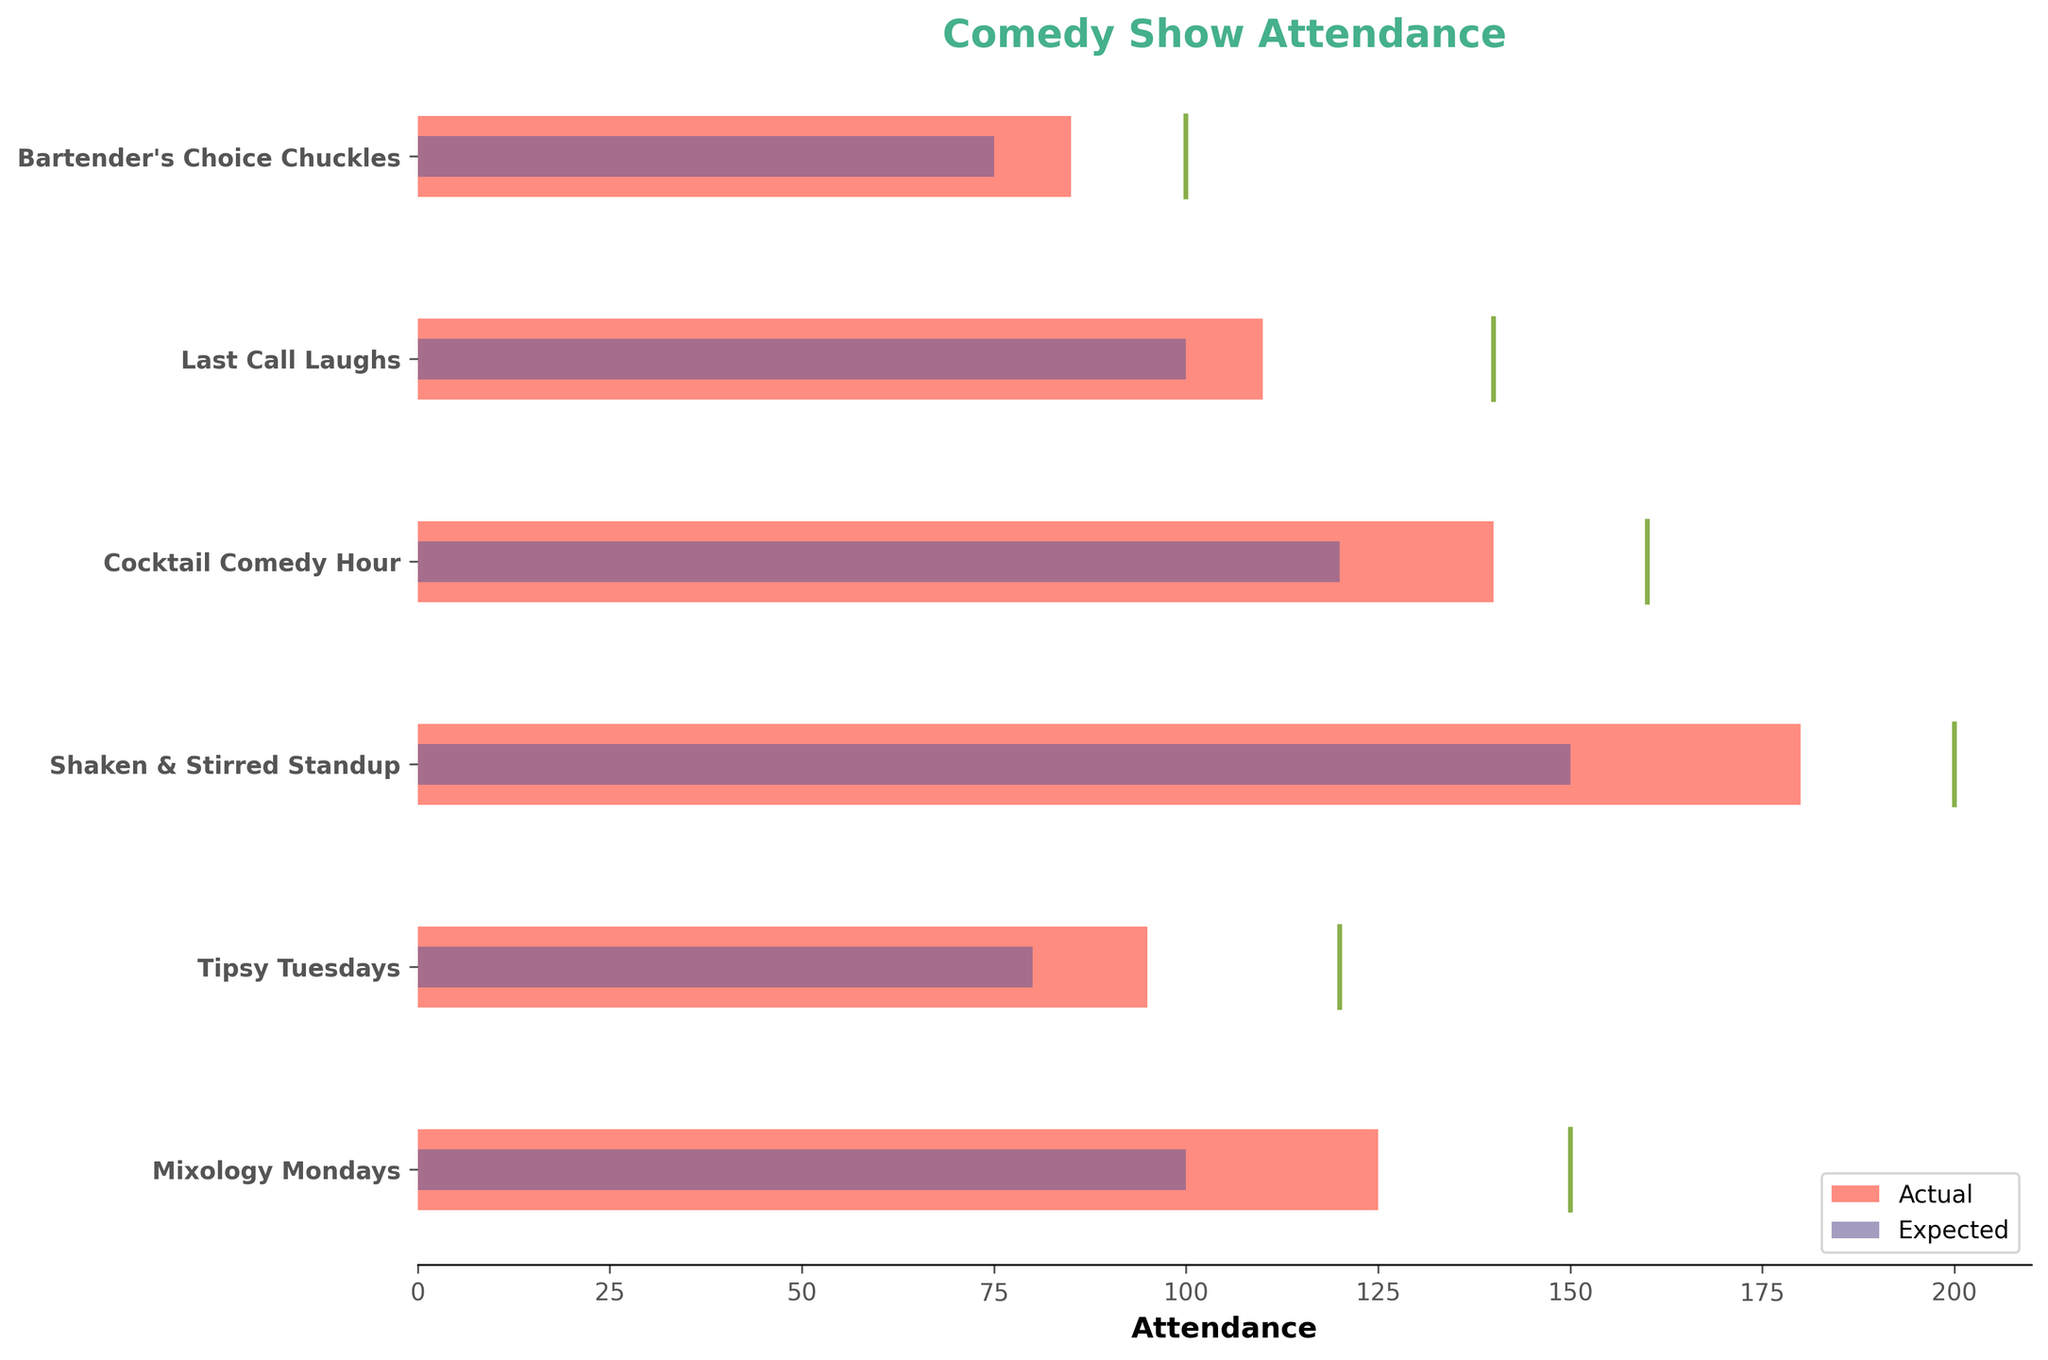What's the title of the figure? The title is located at the top center of the figure and is highlighted in a large, bold font using a distinct color.
Answer: Comedy Show Attendance How many comedy shows are displayed in the figure? Count the number of rows in the visual, with each row corresponding to a different comedy show in the dataset.
Answer: 6 Which comedy show had the highest actual attendance? Identify the longest bar representing actual attendance, which visually indicates higher values.
Answer: Shaken & Stirred Standup What is the maximum capacity for the Cocktail Comedy Hour show? Find the "Cocktail Comedy Hour" row and look at the corresponding vertical line representing maximum capacity next to the bar.
Answer: 160 How much higher was the actual attendance than the expected attendance for Last Call Laughs? Look at the actual and expected attendance bars for "Last Call Laughs" and calculate the difference between them.
Answer: 10 What is the average expected attendance across all comedy shows? Sum the expected attendance values for all shows and divide by the number of shows. (100+80+150+120+100+75)/6
Answer: 104.17 Compare Mixology Mondays and Bartender's Choice Chuckles. Which one had a closer actual attendance to its maximum capacity? Determine the differences between actual attendance and maximum capacity for both shows, then compare the two differences. Mixology Mondays: 150-125=25, Bartender's Choice Chuckles: 100-85=15.
Answer: Bartender's Choice Chuckles Which show exceeded its expected attendance by the largest margin? For each show, subtract the expected attendance from the actual attendance, then identify the show with the highest result.
Answer: Shaken & Stirred Standup Out of all the shows, which one had an actual attendance closest to 100? Identify and compare the attendance bars to the value of 100, then find the closest match.
Answer: Mixology Mondays Is there any show where the actual attendance exactly matched the expected attendance? Compare the lengths of the actual and expected attendance bars for each show to see if any two bars match in length perfectly.
Answer: No 